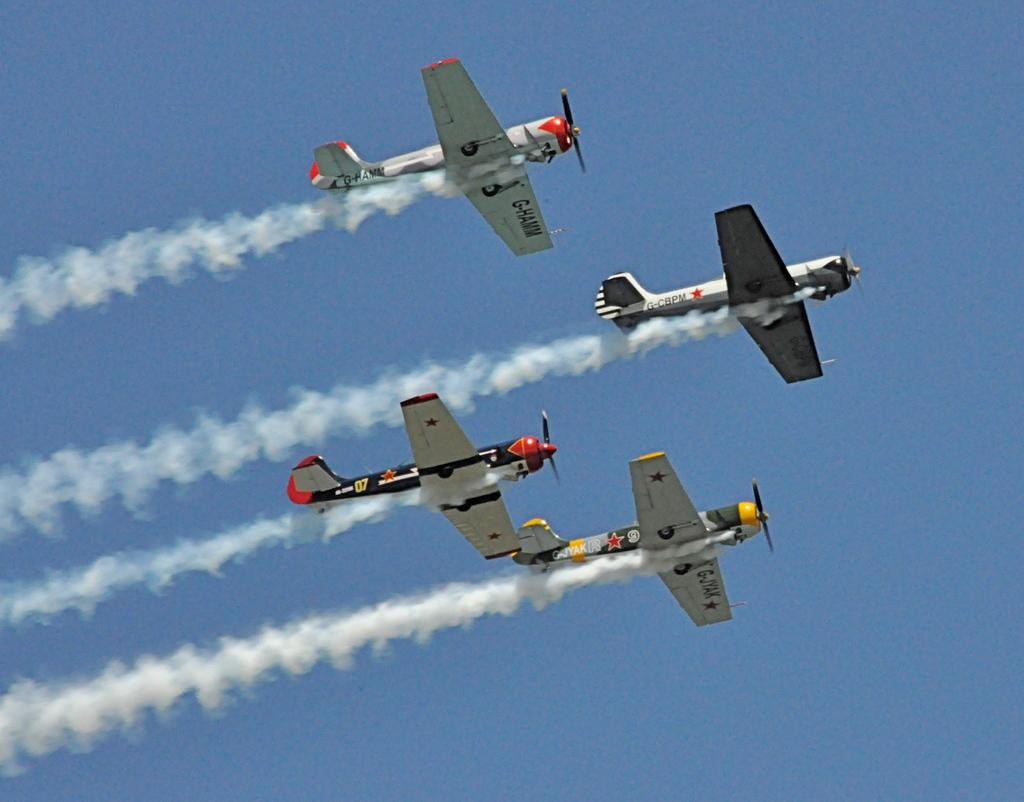What is the main subject of the image? The main subject of the image is an airplane. What is the airplane doing in the image? The airplane is flying in the sky. What feature can be seen on the airplane? The airplane has a propeller and wings. What is the color of the sky in the image? The sky is blue in color. Can you tell me how many birds are flying alongside the airplane in the image? There are no birds visible in the image; it only features an airplane flying in the sky. What type of bubble can be seen in the image? There are no bubbles present in the image. 